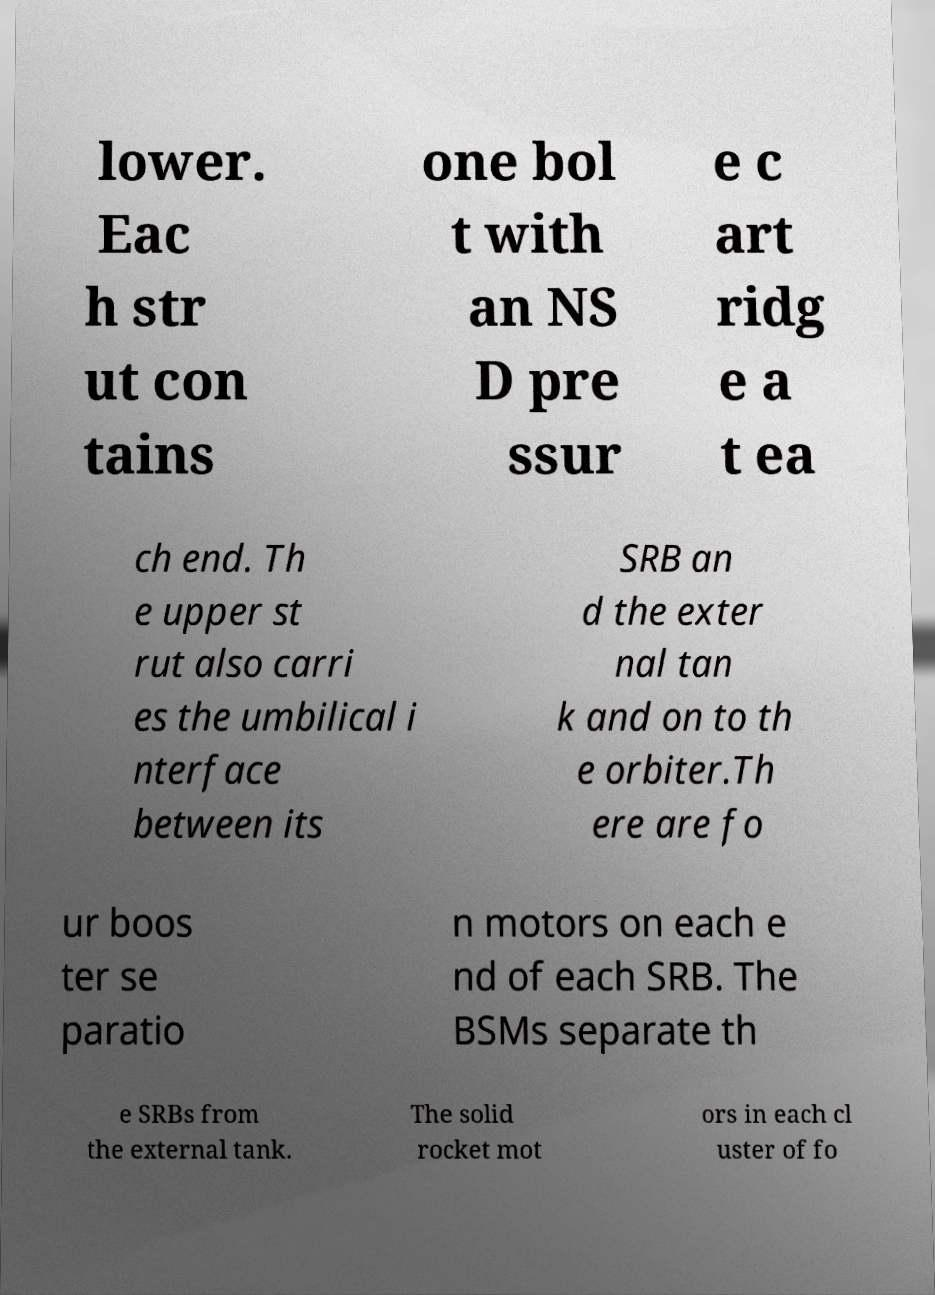Could you assist in decoding the text presented in this image and type it out clearly? lower. Eac h str ut con tains one bol t with an NS D pre ssur e c art ridg e a t ea ch end. Th e upper st rut also carri es the umbilical i nterface between its SRB an d the exter nal tan k and on to th e orbiter.Th ere are fo ur boos ter se paratio n motors on each e nd of each SRB. The BSMs separate th e SRBs from the external tank. The solid rocket mot ors in each cl uster of fo 